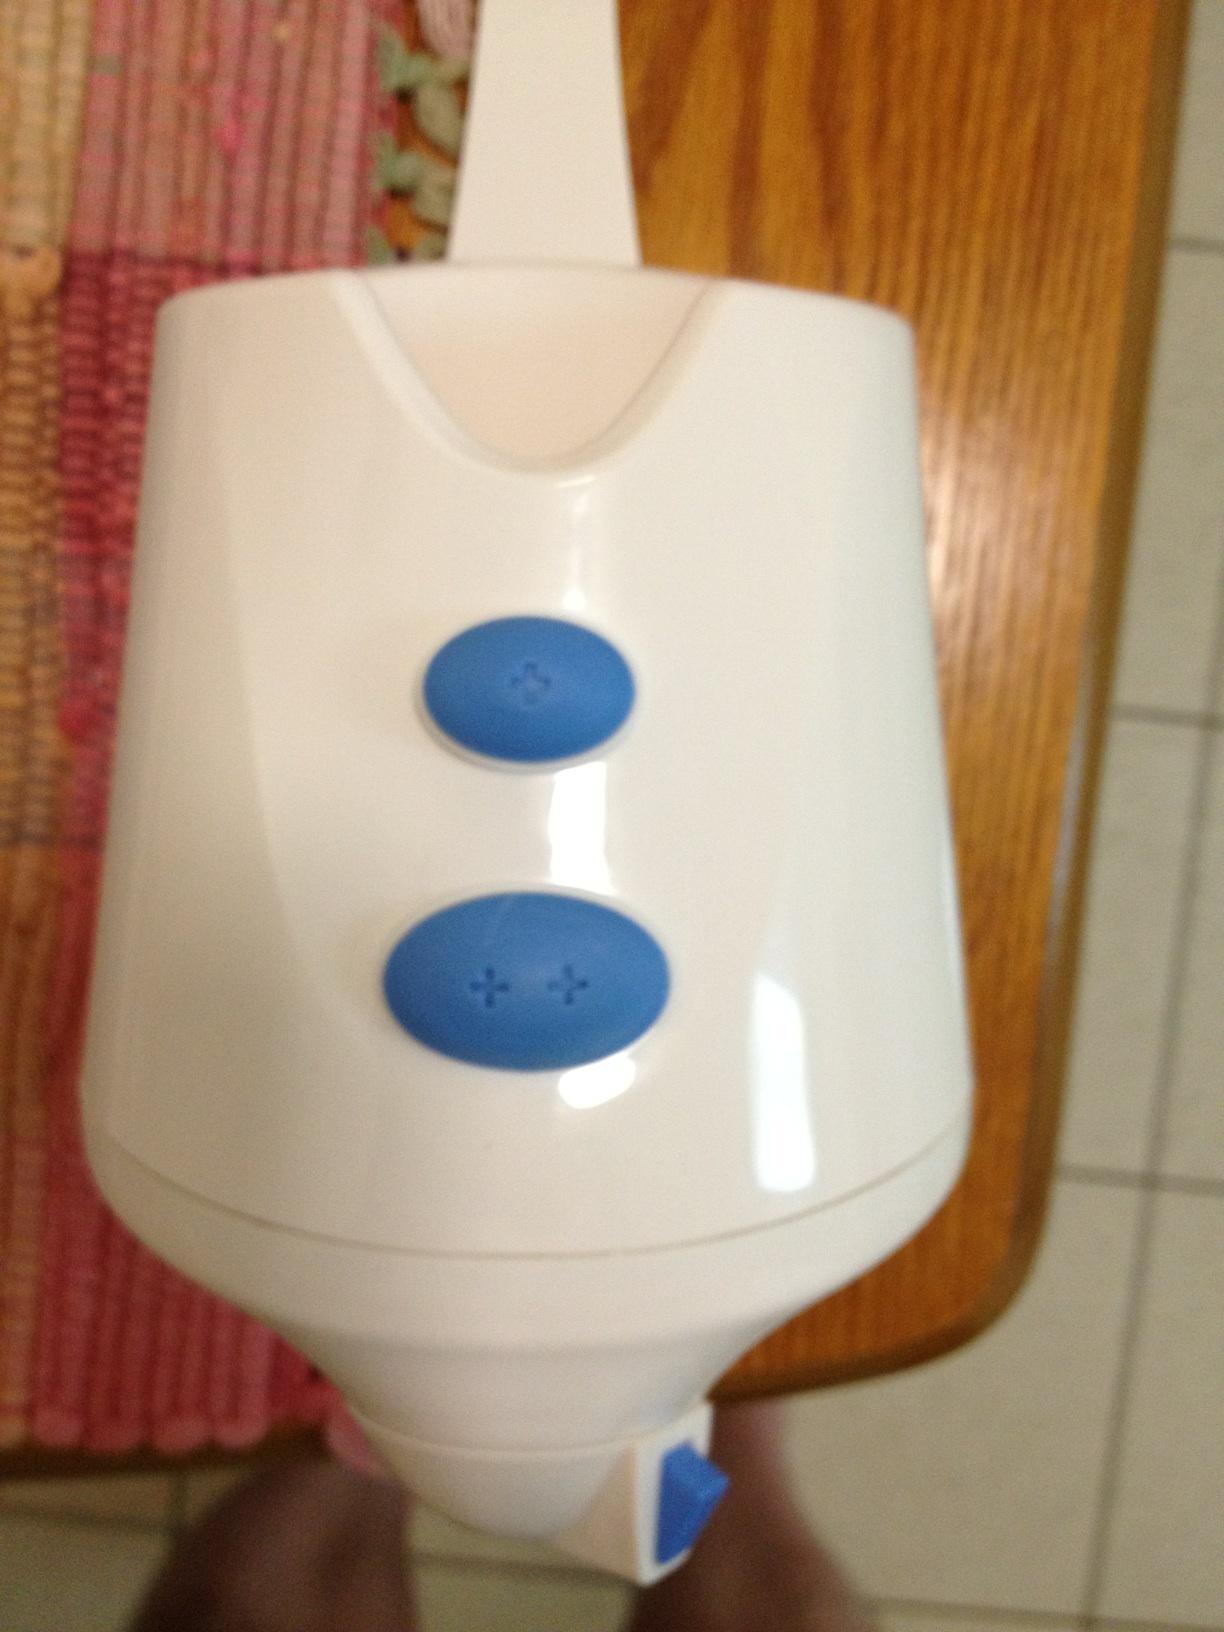What is the writing on the two buttons and which one is which? The two buttons have plus signs; the top button has a single plus sign, while the bottom one has a double plus sign. They are both likely used to adjust settings or power on the device. 